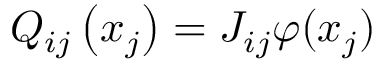<formula> <loc_0><loc_0><loc_500><loc_500>Q _ { i j } \left ( x _ { j } \right ) = J _ { i j } \varphi ( x _ { j } )</formula> 